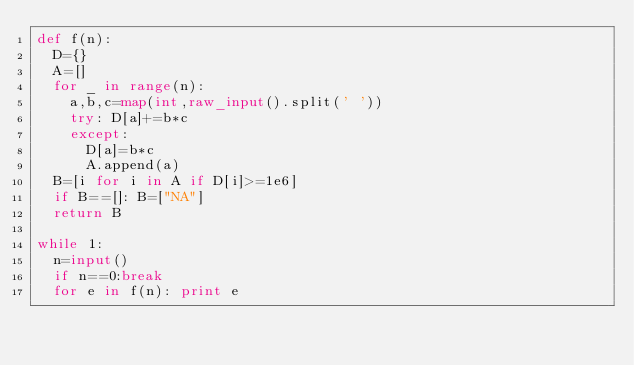<code> <loc_0><loc_0><loc_500><loc_500><_Python_>def f(n):
  D={}
  A=[]
  for _ in range(n):
    a,b,c=map(int,raw_input().split(' '))
    try: D[a]+=b*c
    except:
      D[a]=b*c
      A.append(a)
  B=[i for i in A if D[i]>=1e6]
  if B==[]: B=["NA"]
  return B

while 1:
  n=input()
  if n==0:break
  for e in f(n): print e</code> 